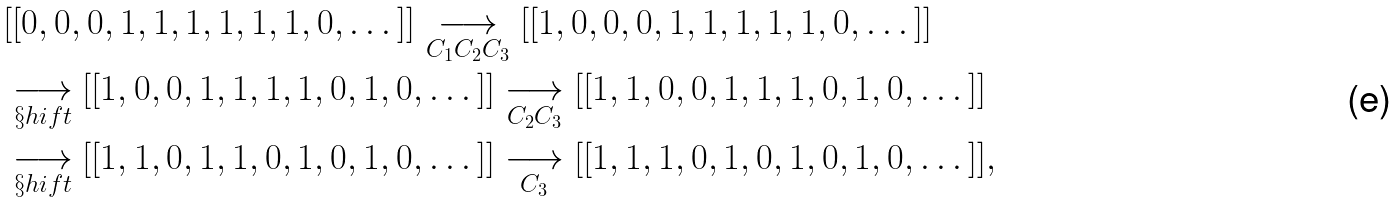Convert formula to latex. <formula><loc_0><loc_0><loc_500><loc_500>& [ [ 0 , 0 , 0 , 1 , 1 , 1 , 1 , 1 , 1 , 0 , \dots ] ] \underset { C _ { 1 } C _ { 2 } C _ { 3 } } { \longrightarrow } [ [ 1 , 0 , 0 , 0 , 1 , 1 , 1 , 1 , 1 , 0 , \dots ] ] \\ & \underset { \S h i f t } { \longrightarrow } [ [ 1 , 0 , 0 , 1 , 1 , 1 , 1 , 0 , 1 , 0 , \dots ] ] \underset { C _ { 2 } C _ { 3 } } { \longrightarrow } [ [ 1 , 1 , 0 , 0 , 1 , 1 , 1 , 0 , 1 , 0 , \dots ] ] \\ & \underset { \S h i f t } { \longrightarrow } [ [ 1 , 1 , 0 , 1 , 1 , 0 , 1 , 0 , 1 , 0 , \dots ] ] \underset { C _ { 3 } } { \longrightarrow } [ [ 1 , 1 , 1 , 0 , 1 , 0 , 1 , 0 , 1 , 0 , \dots ] ] ,</formula> 